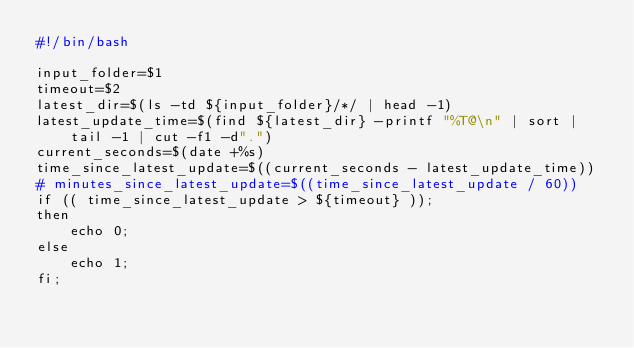<code> <loc_0><loc_0><loc_500><loc_500><_Bash_>#!/bin/bash

input_folder=$1
timeout=$2
latest_dir=$(ls -td ${input_folder}/*/ | head -1)
latest_update_time=$(find ${latest_dir} -printf "%T@\n" | sort | tail -1 | cut -f1 -d".")
current_seconds=$(date +%s)
time_since_latest_update=$((current_seconds - latest_update_time))
# minutes_since_latest_update=$((time_since_latest_update / 60))
if (( time_since_latest_update > ${timeout} ));
then 
    echo 0;
else
    echo 1;
fi;</code> 